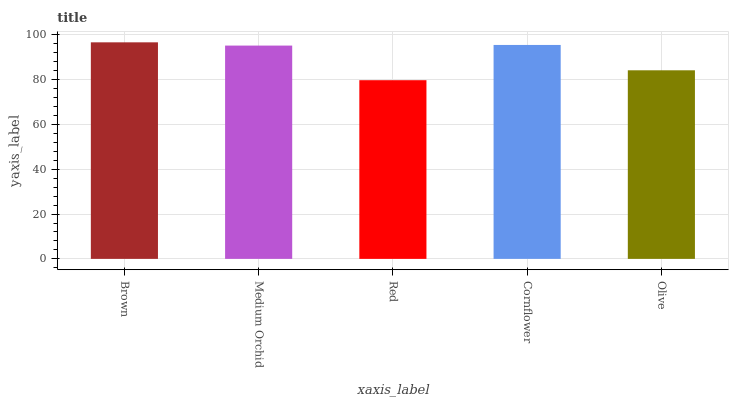Is Red the minimum?
Answer yes or no. Yes. Is Brown the maximum?
Answer yes or no. Yes. Is Medium Orchid the minimum?
Answer yes or no. No. Is Medium Orchid the maximum?
Answer yes or no. No. Is Brown greater than Medium Orchid?
Answer yes or no. Yes. Is Medium Orchid less than Brown?
Answer yes or no. Yes. Is Medium Orchid greater than Brown?
Answer yes or no. No. Is Brown less than Medium Orchid?
Answer yes or no. No. Is Medium Orchid the high median?
Answer yes or no. Yes. Is Medium Orchid the low median?
Answer yes or no. Yes. Is Red the high median?
Answer yes or no. No. Is Brown the low median?
Answer yes or no. No. 